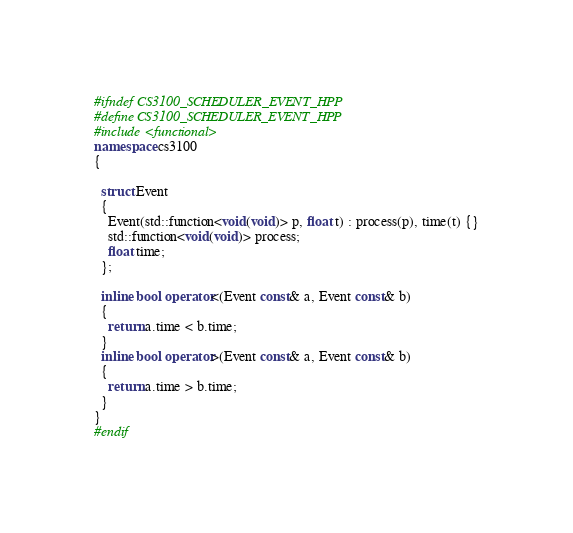<code> <loc_0><loc_0><loc_500><loc_500><_C++_>#ifndef CS3100_SCHEDULER_EVENT_HPP
#define CS3100_SCHEDULER_EVENT_HPP
#include <functional>
namespace cs3100
{

  struct Event
  {
    Event(std::function<void(void)> p, float t) : process(p), time(t) {}
    std::function<void(void)> process;
    float time;
  };

  inline bool operator<(Event const& a, Event const& b)
  {
    return a.time < b.time;
  }
  inline bool operator>(Event const& a, Event const& b)
  {
    return a.time > b.time;
  }
}
#endif
</code> 